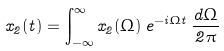Convert formula to latex. <formula><loc_0><loc_0><loc_500><loc_500>x _ { 2 } ( t ) = \int _ { - \infty } ^ { \infty } x _ { 2 } ( \Omega ) \, e ^ { - i \Omega t } \, \frac { d \Omega } { 2 \pi }</formula> 